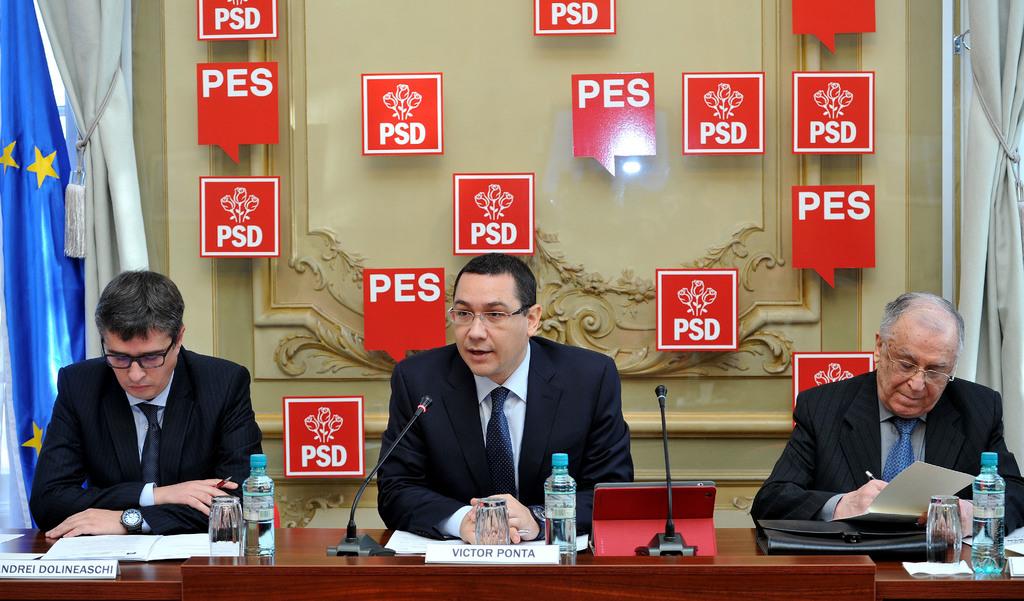What is the man's name who is sitting in the middle?
Make the answer very short. Victor ponta. 